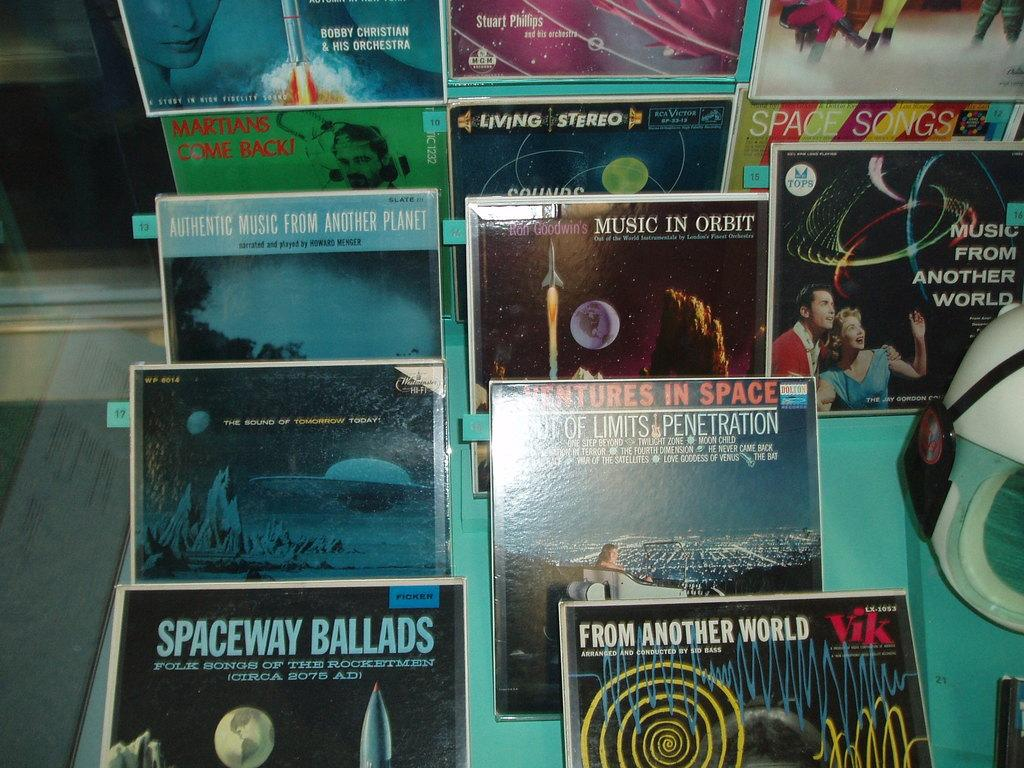Provide a one-sentence caption for the provided image. Spaceway Ballads is one type of album on display. 